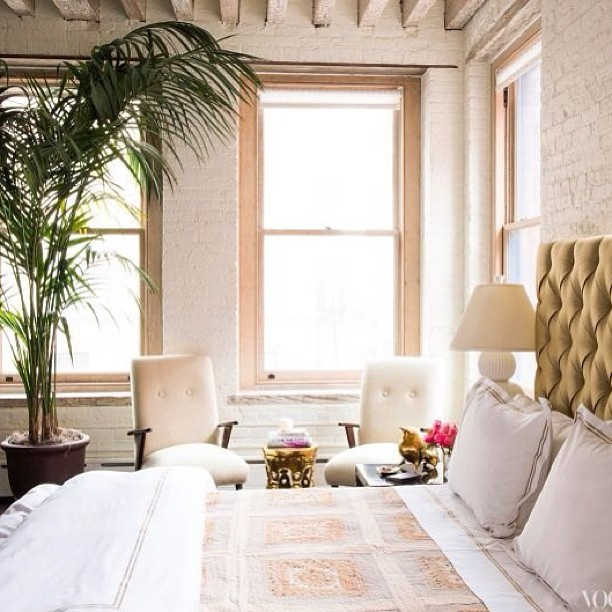Describe the objects in this image and their specific colors. I can see bed in black, lightgray, and darkgray tones, potted plant in black, ivory, darkgreen, and gray tones, chair in black, lightgray, and tan tones, and chair in black, lightgray, tan, and darkgray tones in this image. 